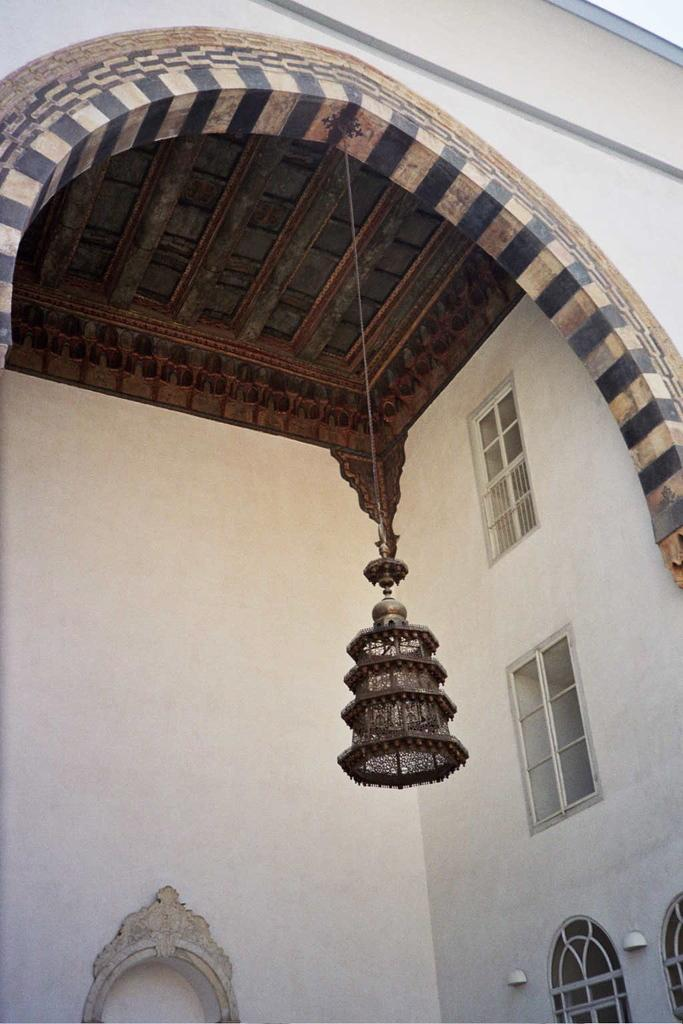What is hanging from the roof of the building in the image? There is a lamp hanging from the roof of a building in the image. What can be seen in the wall of the building? There are windows in the wall of the building. Where are additional lights located in the image? There are lights attached to the wall at the right bottom in the image. What type of railway is visible in the image? There is no railway present in the image. What kind of vessel is being used to transport goods in the image? There is no vessel present in the image. 